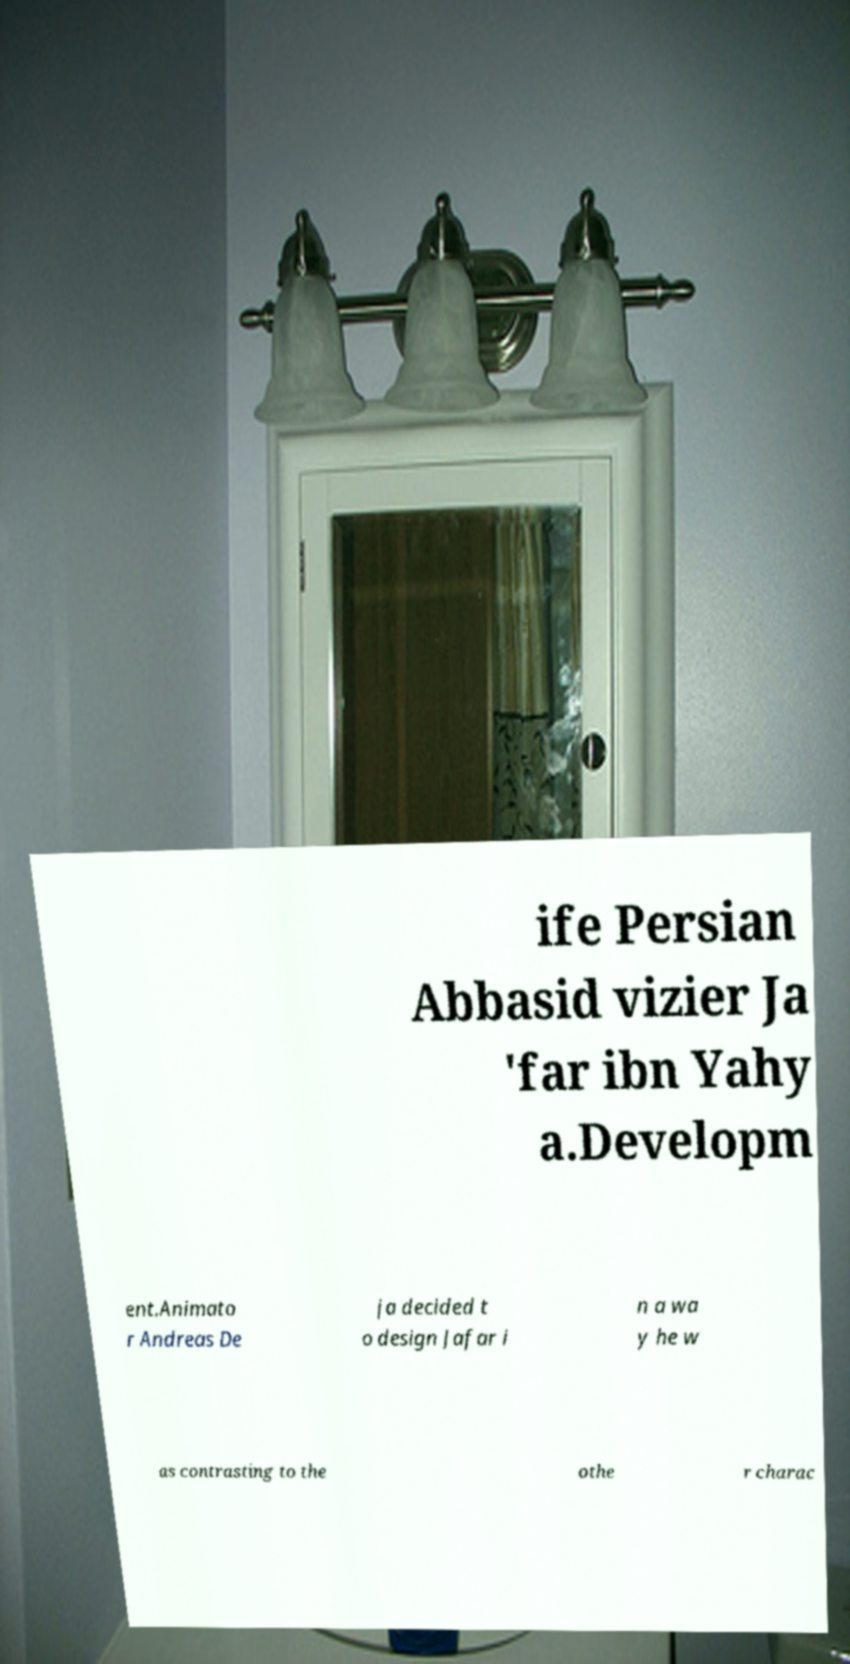Could you assist in decoding the text presented in this image and type it out clearly? ife Persian Abbasid vizier Ja 'far ibn Yahy a.Developm ent.Animato r Andreas De ja decided t o design Jafar i n a wa y he w as contrasting to the othe r charac 